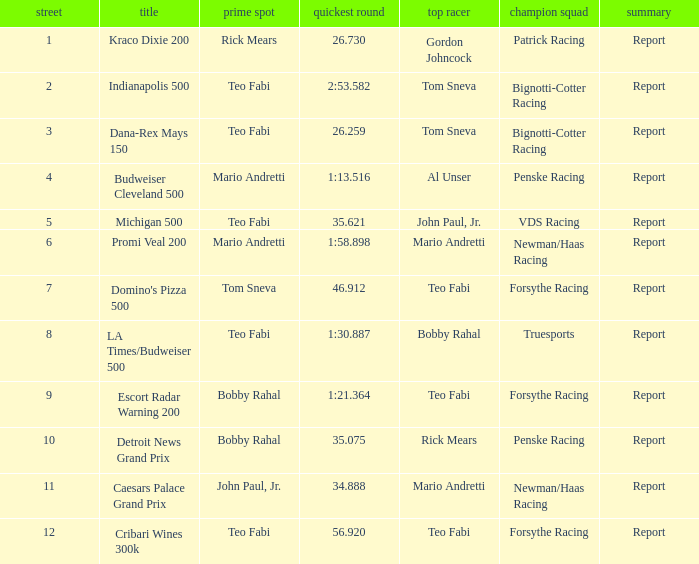What was the fastest lap time in the Escort Radar Warning 200? 1:21.364. 